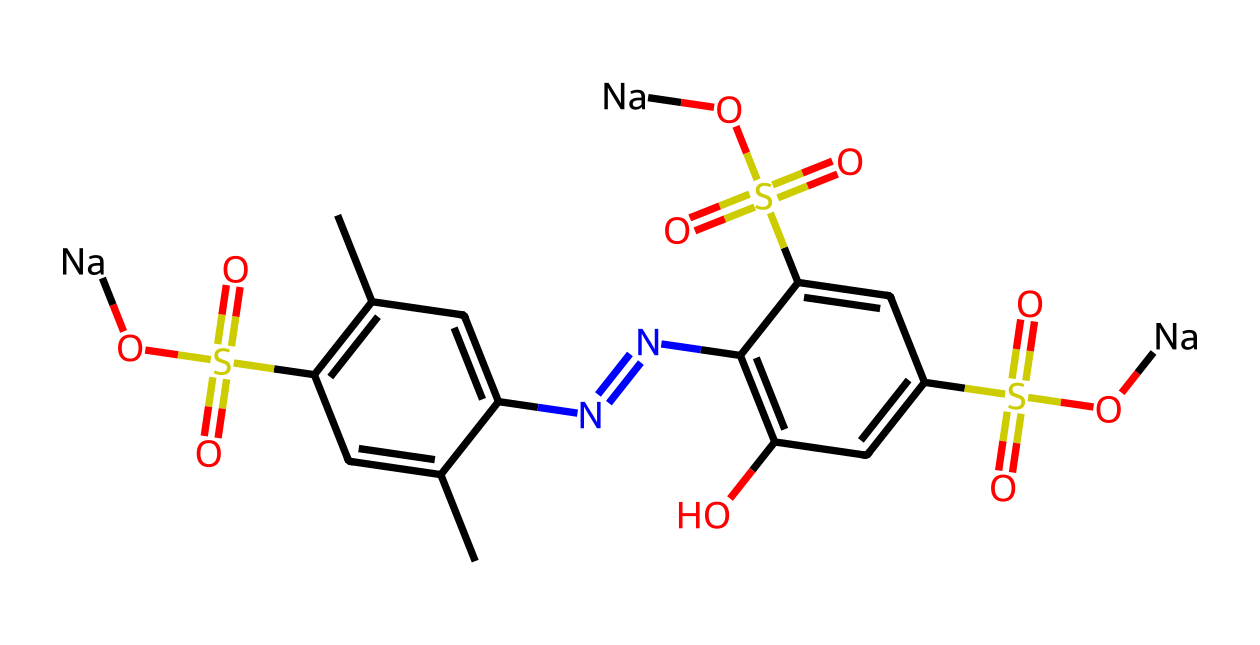What is the main functional group present in this dye? The presence of the sulfonic acid groups, indicated by the 'S(=O)(=O)O' pattern, shows that sulfonic acid is a main functional group in the structure.
Answer: sulfonic acid How many sodium ions are present in this chemical? Upon examining the structure, there are two instances of '[Na]' attached to the sulfonic acid groups, indicating the presence of two sodium ions in total.
Answer: 2 What type of compound is this dye classified as? Given that this structure includes aromatic rings and contains various functional groups, including sulfonic acids, it can be classified as an azo dye, which typically has nitrogen double bonds linking aromatic systems.
Answer: azo dye How many rings are present in the structure? The structure consists of two fused aromatic rings which can be counted from the cyclic components in the SMILES representation.
Answer: 2 What is the color property of the dye likely due to? The color property is typically attributed to the conjugated system present in the aromatic rings and the azo group, as extensive delocalization of electrons in these structures absorbs specific wavelengths of light.
Answer: conjugated system Which element in the structure is primarily responsible for its acidity? The sulfonic acid groups, characterized by the sulfur atom bonded to three oxygens (one doubly bonded) and the hydroxyl group, contribute to the acidity of this dye due to the highly polarized S-O and O-H bonds.
Answer: sulfur 